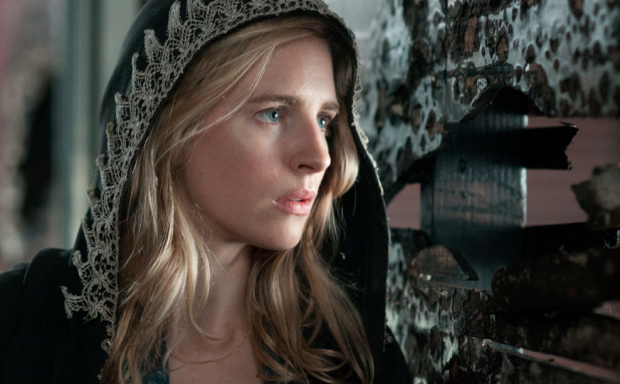Can you describe the emotional tone of the scene? The emotional tone of the scene is one of suspense and introspection. The woman's serious expression and the dark, worn backdrop convey a sense of foreboding and mystery. Her gaze off into the distance suggests she is either anticipating a significant event or deeply lost in thought, adding a layer of tension to the scene. 